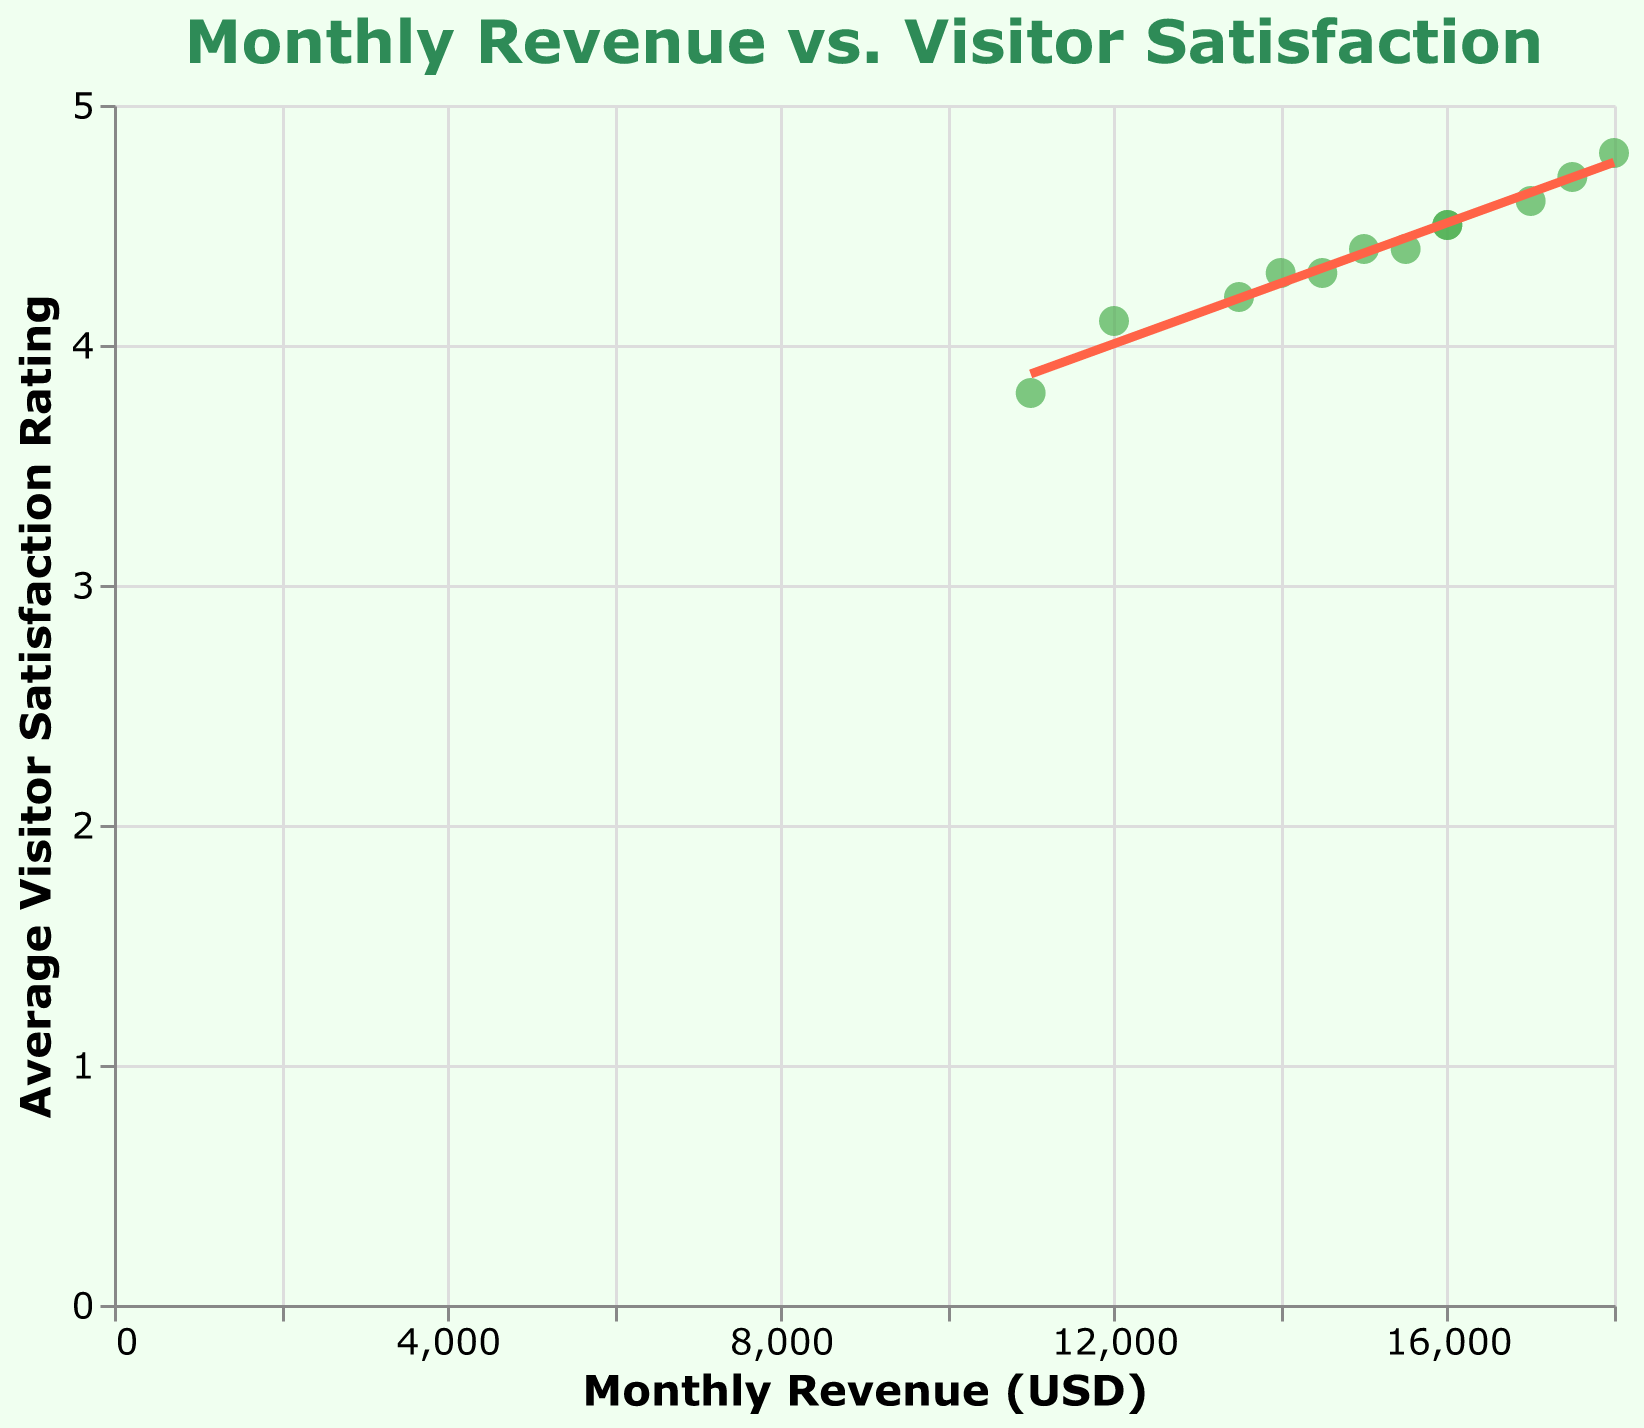What is the title of the figure? The title is usually displayed at the top of the figure and describes the main subject or relationship shown in the chart. In this case, the title should reflect the relationship between revenue and visitor satisfaction.
Answer: Monthly Revenue vs. Visitor Satisfaction How many data points are plotted on the scatter plot? Each data point represents one month, and you can count the number of months listed in the data section to find the total number of data points. There are points for January through December, making it 12 points in total.
Answer: 12 What is the average visitor satisfaction rating for May? To find the average visitor satisfaction rating for May, locate the May data point in the tooltip information when hovering over or referencing the data. The average visitor satisfaction rating for May is 4.5.
Answer: 4.5 Which month shows the highest average visitor satisfaction rating and what is the corresponding revenue? Look at the tooltip information of the data point with the highest Y-value on the scatter plot. July has the highest satisfaction rating of 4.8, with a corresponding revenue of 18000 USD.
Answer: July, 18000 USD Is there a general trend in revenue as visitor satisfaction rating increases? Observe the direction and slope of the trend line. If the trend line moves upward from left to right, it indicates a positive correlation between visitor satisfaction and revenue, meaning revenue generally increases as visitor satisfaction increases.
Answer: Yes, there is a positive correlation What is the general range of revenue values represented on the X-axis? The X-axis represents the revenue values, and examining the data points and the axis range will show the range of revenue values. The revenue ranges from 11000 to 18000 USD.
Answer: 11000 to 18000 USD Which month had the lowest revenue and what was the visitor satisfaction rating that month? Find the data point with the lowest X-value on the scatter plot, and refer to the tooltip information. February has the lowest revenue of 11000 USD, with a satisfaction rating of 3.8.
Answer: February, 3.8 Estimate how much revenue increases on average with a one-point increase in visitor satisfaction rating according to the trend line. The slope of the trend line represents the average change in the Y-variable (revenue) for each unit change in the X-variable (satisfaction rating). By looking at the steepness or regression statistics, you can estimate this average increase. For this example, as the trend line equation is not given, a rough estimate can be made that revenue increases by approximately 2000-3000 USD with a one-point increase in satisfaction rating.
Answer: Approximately 2000-3000 USD 